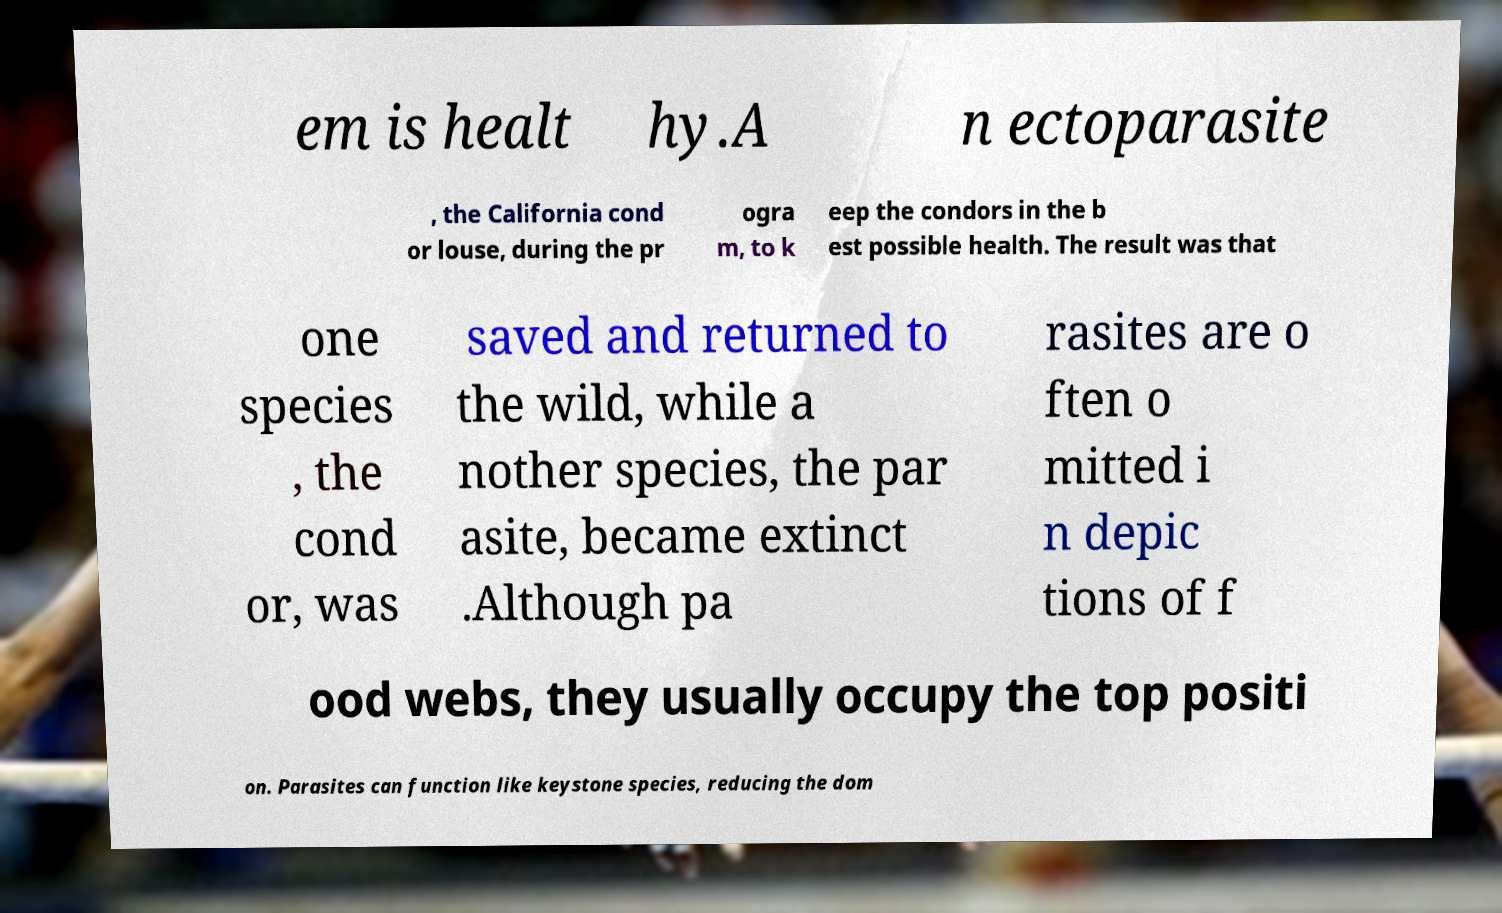Can you accurately transcribe the text from the provided image for me? em is healt hy.A n ectoparasite , the California cond or louse, during the pr ogra m, to k eep the condors in the b est possible health. The result was that one species , the cond or, was saved and returned to the wild, while a nother species, the par asite, became extinct .Although pa rasites are o ften o mitted i n depic tions of f ood webs, they usually occupy the top positi on. Parasites can function like keystone species, reducing the dom 